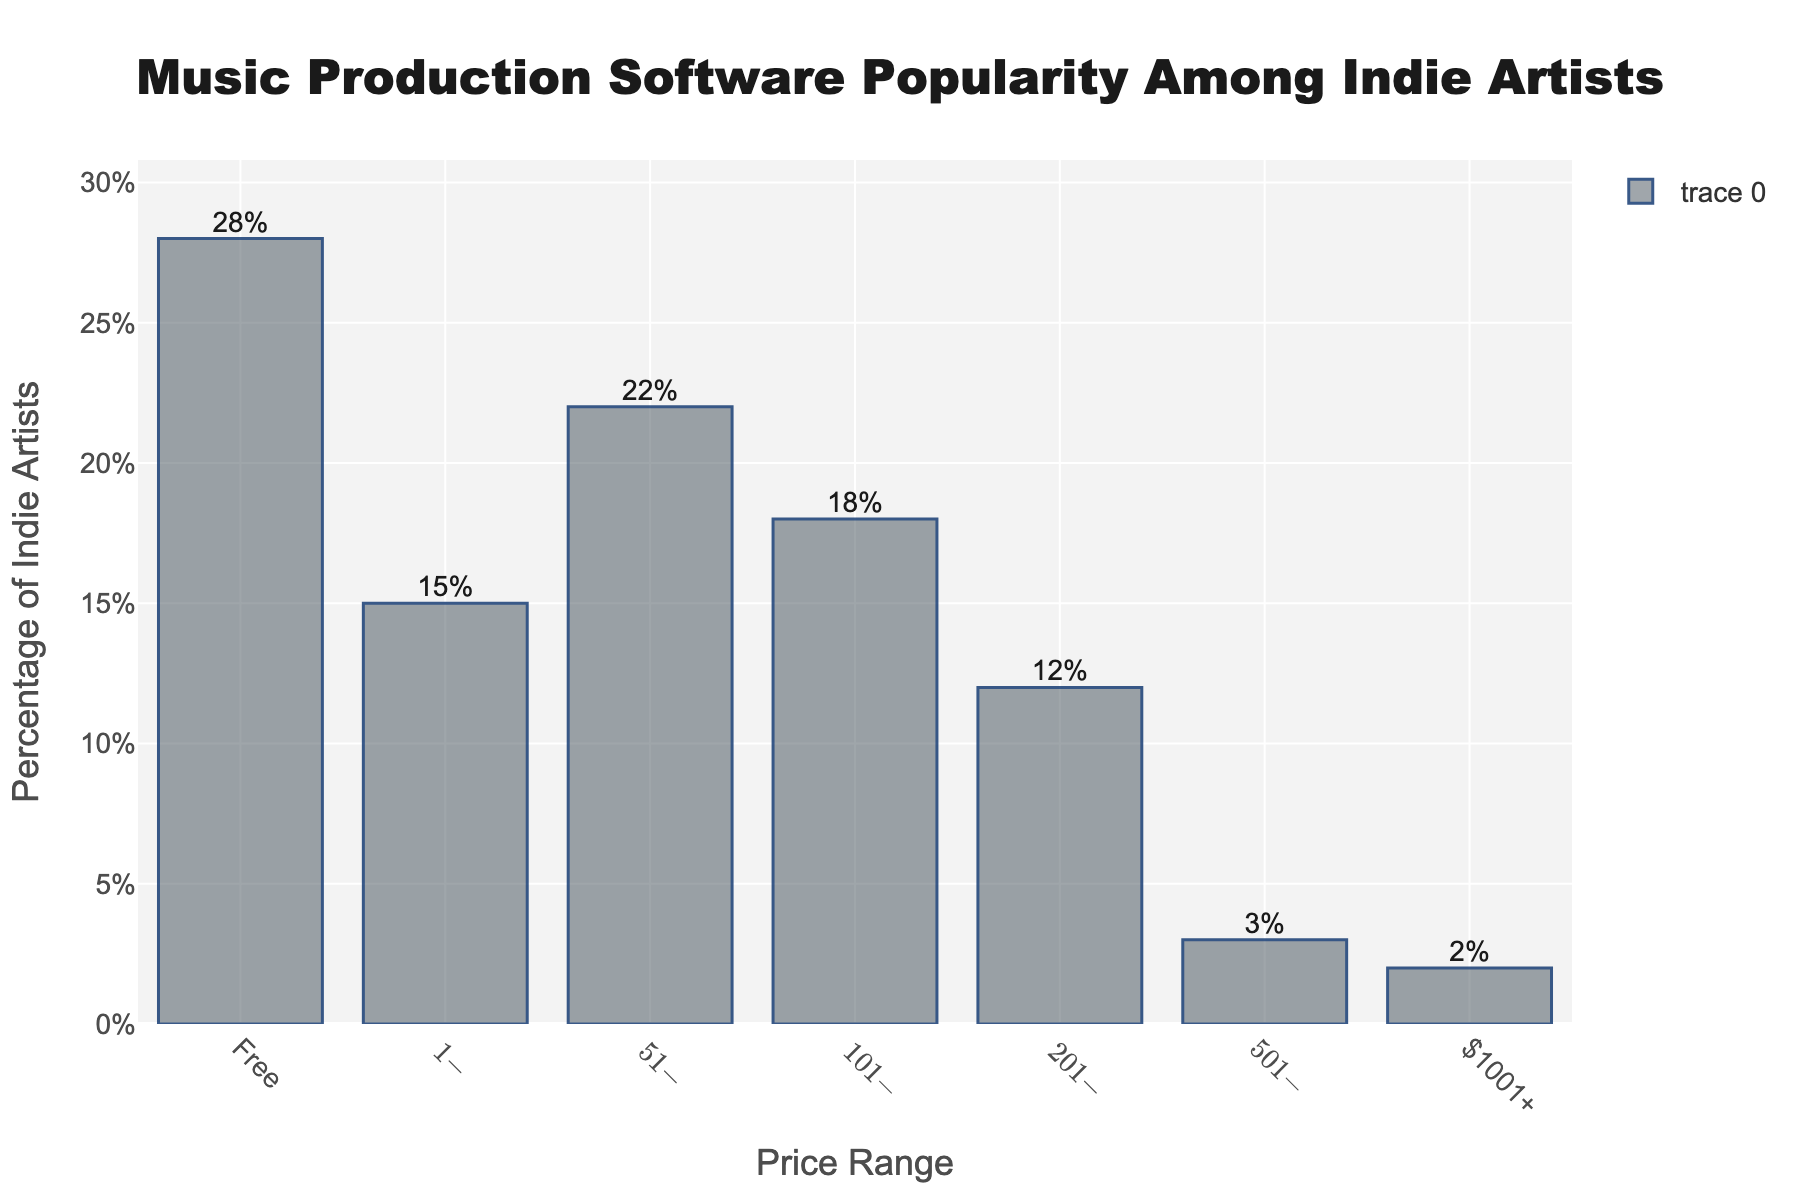What is the most popular price range for music production software among indie artists? The highest bar in the chart indicates the most popular price range. The bar corresponding to the "Free" price range is the tallest, showing it as the most popular.
Answer: Free Which price range has the lowest percentage of indie artists using it? The shortest bar in the chart represents the least popular price range. The bar corresponding to the "$1001+" price range is the shortest, making it the least popular.
Answer: $1001+ What's the total percentage of indie artists using software that costs $200 or less? Add the percentages of the "Free", "$1-$50", "$51-$100", and "$101-$200" price ranges. This is 28% + 15% + 22% + 18%.
Answer: 83% What is the percentage difference between the most popular and least popular price ranges? Subtract the percentage of the "$1001+" range from the percentage of the "Free" range. This is 28% - 2%.
Answer: 26% How does the percentage of those using software in the $51-$100 range compare to those using software in the $101-$200 range? Compare the heights of the bars for the "$51-$100" and "$101-$200" price ranges. The "$51-$100" bar is 22% and the "$101-$200" bar is 18%. So, 22% - 18% = 4%.
Answer: 4% higher What is the second most popular price range for music production software among indie artists? The second tallest bar in the chart corresponds to the second most popular price range. The "$51-$100" range has the second tallest bar at 22%.
Answer: $51-$100 Does the percentage of indie artists using free software surpass the combined percentage of those using software priced between $1-$50 and $201-$500? Compare the percentage of the "Free" range (28%) with the sum of "$1-$50" and "$201-$500" (15% + 12% = 27%). Since 28% > 27%, the free software percentage is larger.
Answer: Yes If we combine the percentages of all price ranges above $500, what is the total percentage? Add the percentages of the "$501-$1000" and "$1001+" price ranges. This is 3% + 2%.
Answer: 5% Is there a higher percentage of indie artists using software in the $101-$200 range or the $201-$500 range? Compare the heights of the bars for the "$101-$200" and "$201-$500" price ranges. The "$101-$200" bar represents 18%, and the "$201-$500" bar represents 12%.
Answer: $101-$200 What percentage of indie artists are using paid software (non-free options) that costs $1000 or less? Add the percentages of the "$1-$50", "$51-$100", "$101-$200", "$201-$500", and "$501-$1000" price ranges. This is 15% + 22% + 18% + 12% + 3%.
Answer: 70% 